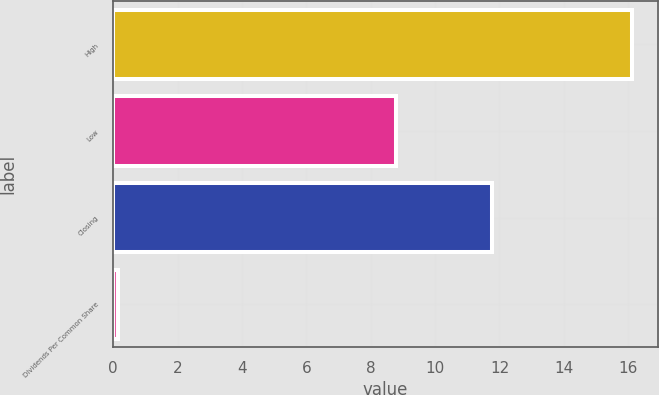<chart> <loc_0><loc_0><loc_500><loc_500><bar_chart><fcel>High<fcel>Low<fcel>Closing<fcel>Dividends Per Common Share<nl><fcel>16.11<fcel>8.8<fcel>11.77<fcel>0.14<nl></chart> 